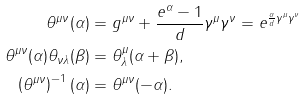<formula> <loc_0><loc_0><loc_500><loc_500>\theta ^ { \mu \nu } ( \alpha ) & = g ^ { \mu \nu } + \frac { e ^ { \alpha } - 1 } { d } \gamma ^ { \mu } \gamma ^ { \nu } = e ^ { \frac { \alpha } { d } \gamma ^ { \mu } \gamma ^ { \nu } } \\ \theta ^ { \mu \nu } ( \alpha ) \theta _ { \nu \lambda } ( \beta ) & = \theta ^ { \mu } _ { \lambda } ( \alpha + \beta ) , \\ \left ( \theta ^ { \mu \nu } \right ) ^ { - 1 } ( \alpha ) & = \theta ^ { \mu \nu } ( - \alpha ) .</formula> 